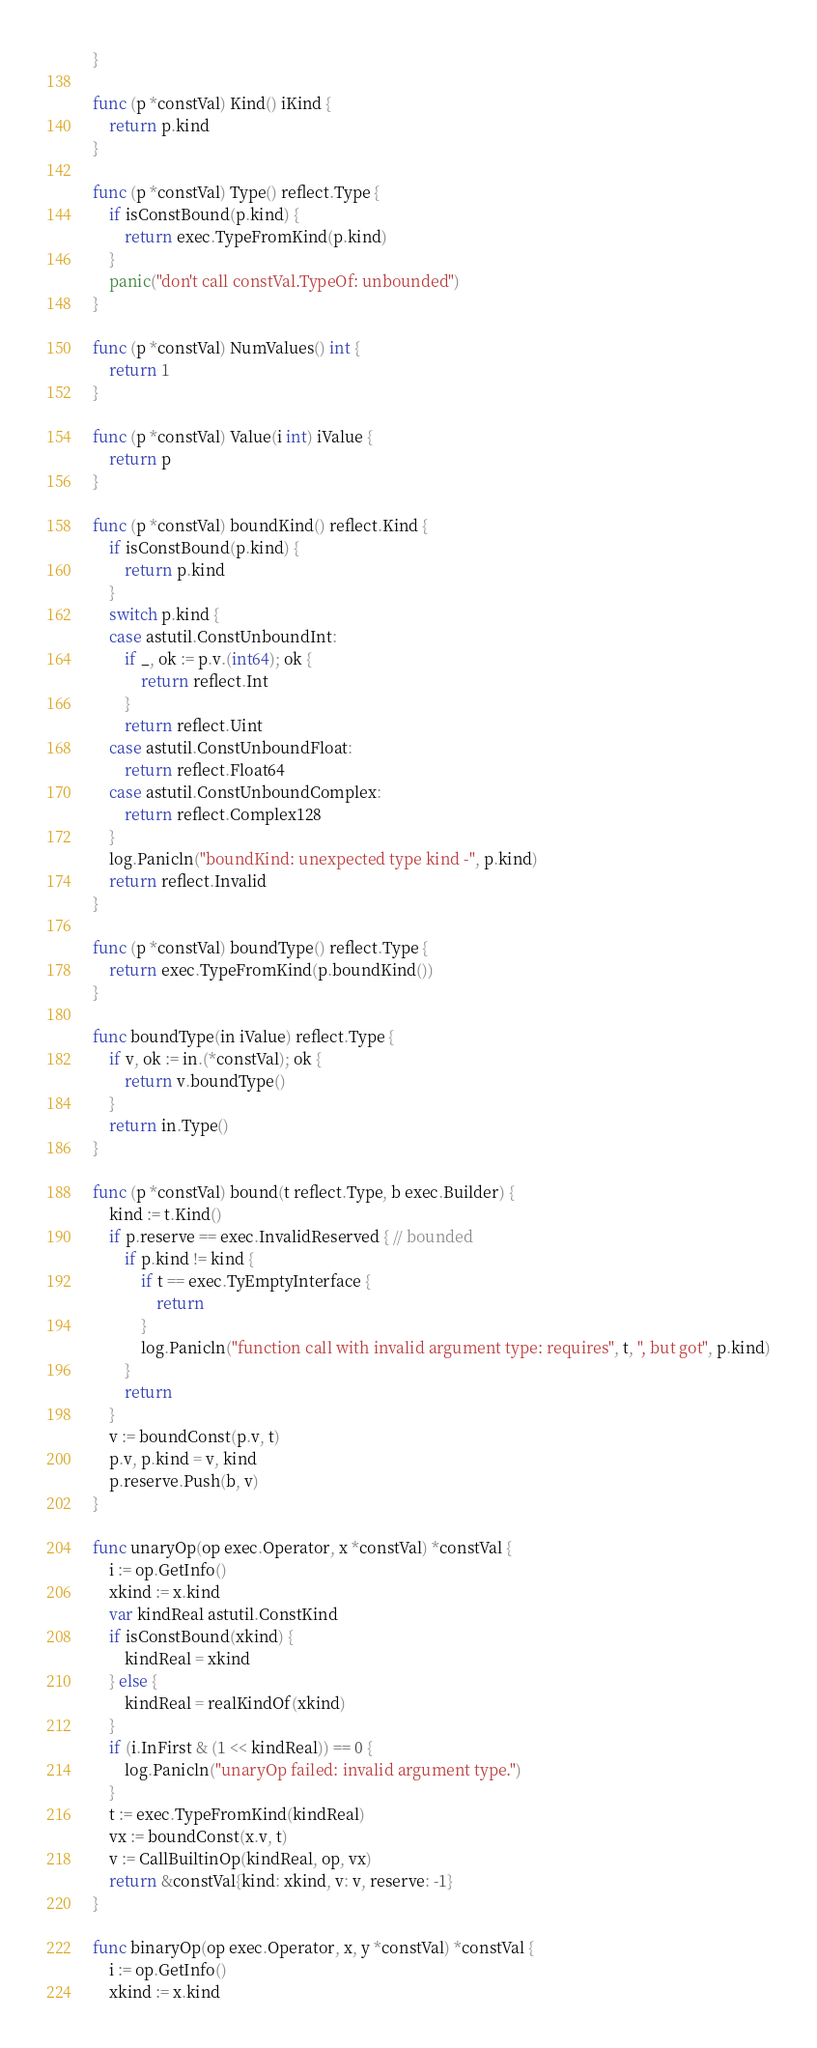Convert code to text. <code><loc_0><loc_0><loc_500><loc_500><_Go_>}

func (p *constVal) Kind() iKind {
	return p.kind
}

func (p *constVal) Type() reflect.Type {
	if isConstBound(p.kind) {
		return exec.TypeFromKind(p.kind)
	}
	panic("don't call constVal.TypeOf: unbounded")
}

func (p *constVal) NumValues() int {
	return 1
}

func (p *constVal) Value(i int) iValue {
	return p
}

func (p *constVal) boundKind() reflect.Kind {
	if isConstBound(p.kind) {
		return p.kind
	}
	switch p.kind {
	case astutil.ConstUnboundInt:
		if _, ok := p.v.(int64); ok {
			return reflect.Int
		}
		return reflect.Uint
	case astutil.ConstUnboundFloat:
		return reflect.Float64
	case astutil.ConstUnboundComplex:
		return reflect.Complex128
	}
	log.Panicln("boundKind: unexpected type kind -", p.kind)
	return reflect.Invalid
}

func (p *constVal) boundType() reflect.Type {
	return exec.TypeFromKind(p.boundKind())
}

func boundType(in iValue) reflect.Type {
	if v, ok := in.(*constVal); ok {
		return v.boundType()
	}
	return in.Type()
}

func (p *constVal) bound(t reflect.Type, b exec.Builder) {
	kind := t.Kind()
	if p.reserve == exec.InvalidReserved { // bounded
		if p.kind != kind {
			if t == exec.TyEmptyInterface {
				return
			}
			log.Panicln("function call with invalid argument type: requires", t, ", but got", p.kind)
		}
		return
	}
	v := boundConst(p.v, t)
	p.v, p.kind = v, kind
	p.reserve.Push(b, v)
}

func unaryOp(op exec.Operator, x *constVal) *constVal {
	i := op.GetInfo()
	xkind := x.kind
	var kindReal astutil.ConstKind
	if isConstBound(xkind) {
		kindReal = xkind
	} else {
		kindReal = realKindOf(xkind)
	}
	if (i.InFirst & (1 << kindReal)) == 0 {
		log.Panicln("unaryOp failed: invalid argument type.")
	}
	t := exec.TypeFromKind(kindReal)
	vx := boundConst(x.v, t)
	v := CallBuiltinOp(kindReal, op, vx)
	return &constVal{kind: xkind, v: v, reserve: -1}
}

func binaryOp(op exec.Operator, x, y *constVal) *constVal {
	i := op.GetInfo()
	xkind := x.kind</code> 